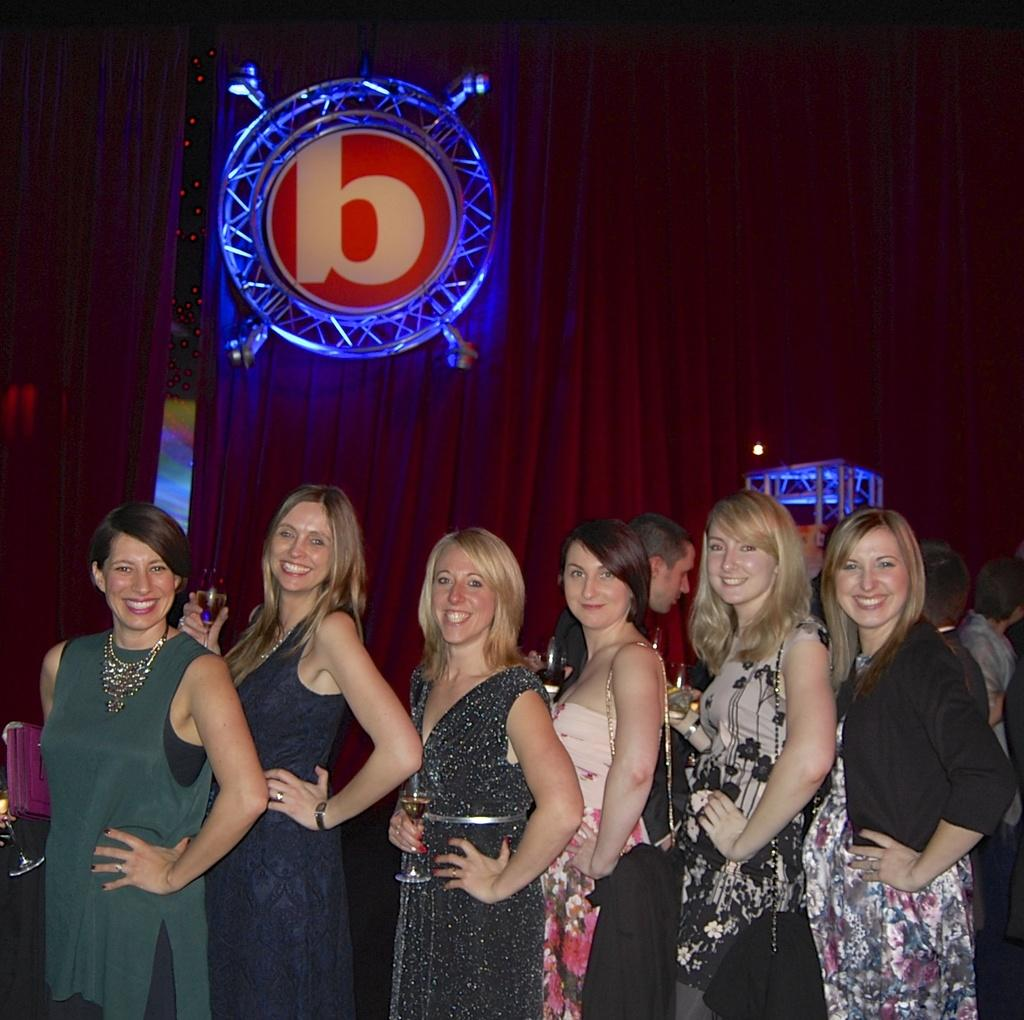How many girls are in the image? There are girls in the image. Where are the girls positioned in the image? The girls are standing in the front. What expression do the girls have in the image? The girls are smiling in the image. What are the girls doing in the image? The girls are posing for the camera in the image. What can be seen in the background of the image? There is a red color curtain and a round iron frame disk. What type of sidewalk can be seen in the image? There is no sidewalk present in the image. Is there a crook in the image? There is no crook present in the image. 